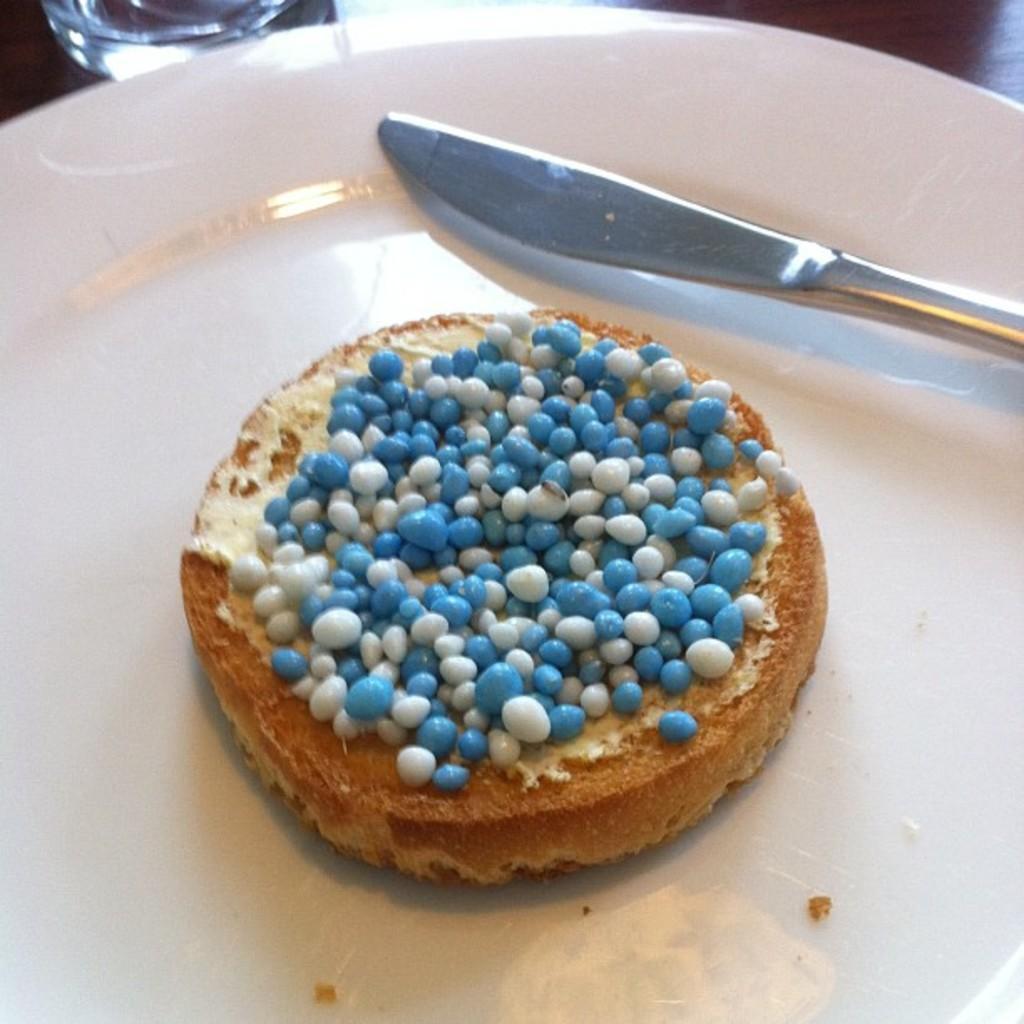Can you describe this image briefly? In the center of the image we can see cake and knife in plate placed on the table. At the top left corner there is glass. 